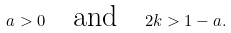<formula> <loc_0><loc_0><loc_500><loc_500>a > 0 \quad \text {and} \quad 2 k > 1 - a .</formula> 